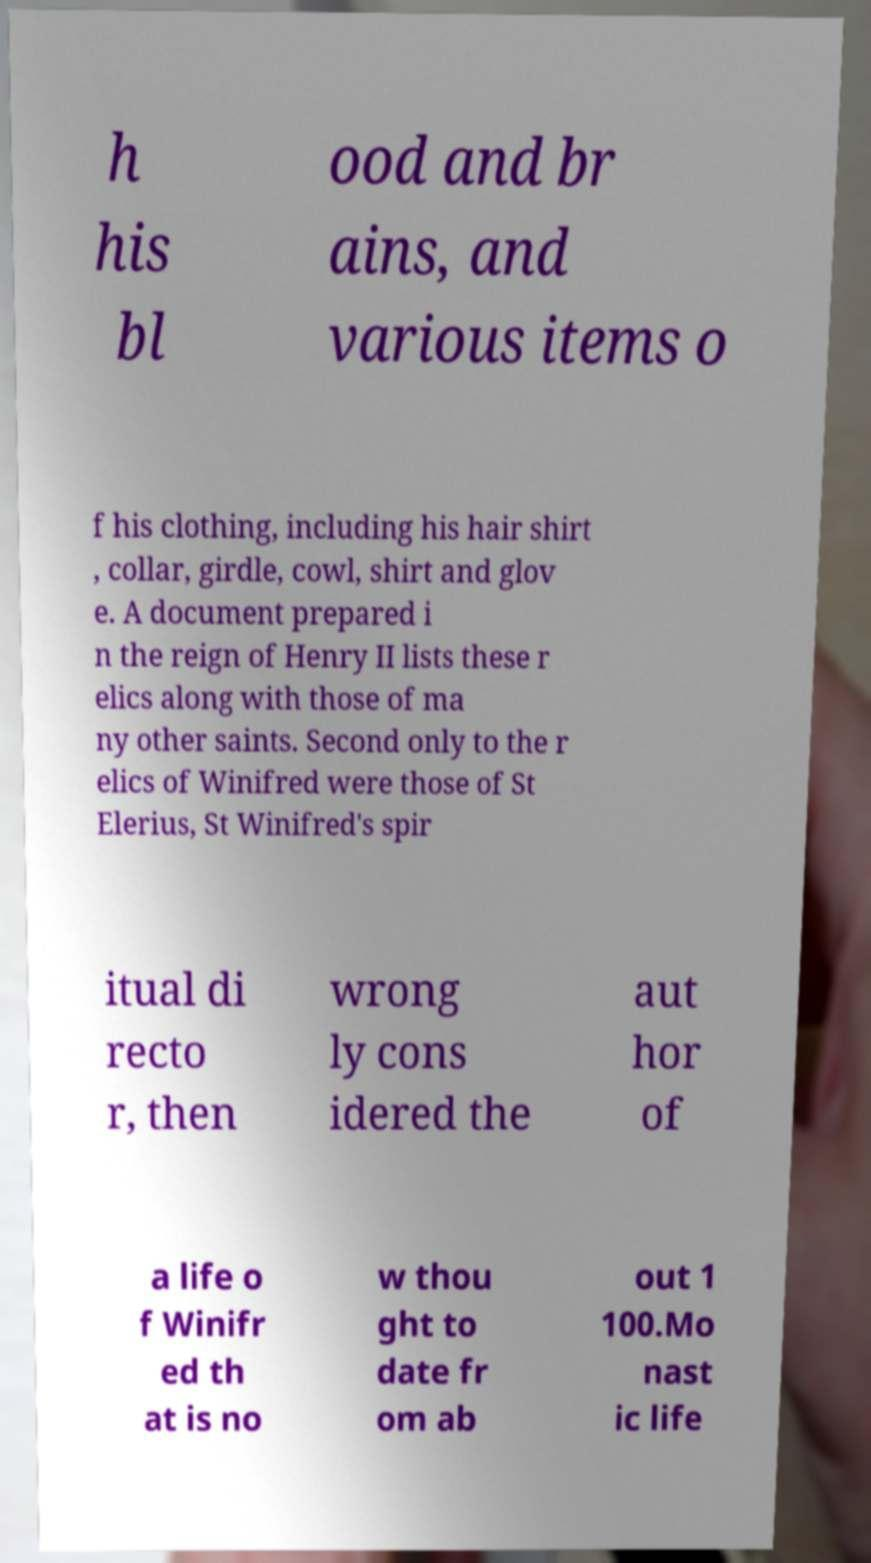Can you accurately transcribe the text from the provided image for me? h his bl ood and br ains, and various items o f his clothing, including his hair shirt , collar, girdle, cowl, shirt and glov e. A document prepared i n the reign of Henry II lists these r elics along with those of ma ny other saints. Second only to the r elics of Winifred were those of St Elerius, St Winifred's spir itual di recto r, then wrong ly cons idered the aut hor of a life o f Winifr ed th at is no w thou ght to date fr om ab out 1 100.Mo nast ic life 